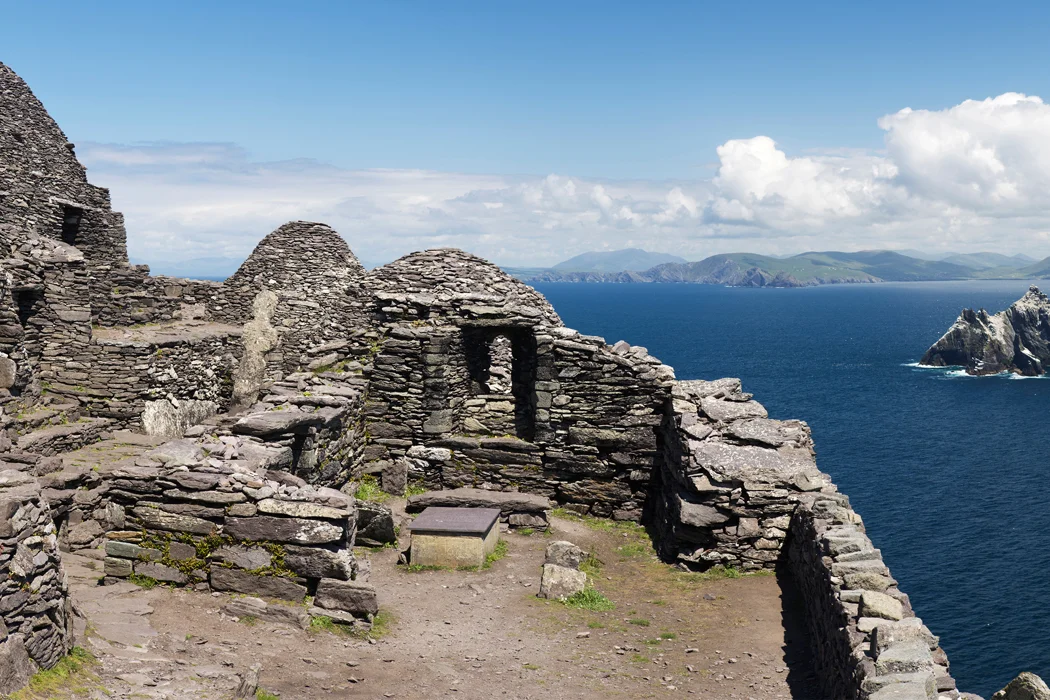Write a detailed description of the given image. The image showcases Skellig Michael, an island off the coast of Ireland renowned for its historical and cultural importance. Visible are the well-preserved remains of a monastic settlement dating back to around the 6th century. This remote site, accessible only by boat, features beehive-like huts constructed from stone without mortar, a testament to the ingenuity of early medieval monks. In the background, the vast Atlantic Ocean stretches towards the horizon, dotted with the faint outlines of other islands, under a sky with scattered clouds that suggests a brisk, clear day. This site is not only a part of the UNESCO World Heritage but also a beacon of solitude, offering insights into the austere lives led by its ancient inhabitants. 